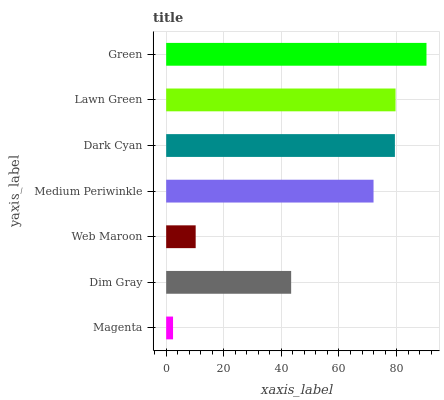Is Magenta the minimum?
Answer yes or no. Yes. Is Green the maximum?
Answer yes or no. Yes. Is Dim Gray the minimum?
Answer yes or no. No. Is Dim Gray the maximum?
Answer yes or no. No. Is Dim Gray greater than Magenta?
Answer yes or no. Yes. Is Magenta less than Dim Gray?
Answer yes or no. Yes. Is Magenta greater than Dim Gray?
Answer yes or no. No. Is Dim Gray less than Magenta?
Answer yes or no. No. Is Medium Periwinkle the high median?
Answer yes or no. Yes. Is Medium Periwinkle the low median?
Answer yes or no. Yes. Is Web Maroon the high median?
Answer yes or no. No. Is Dark Cyan the low median?
Answer yes or no. No. 